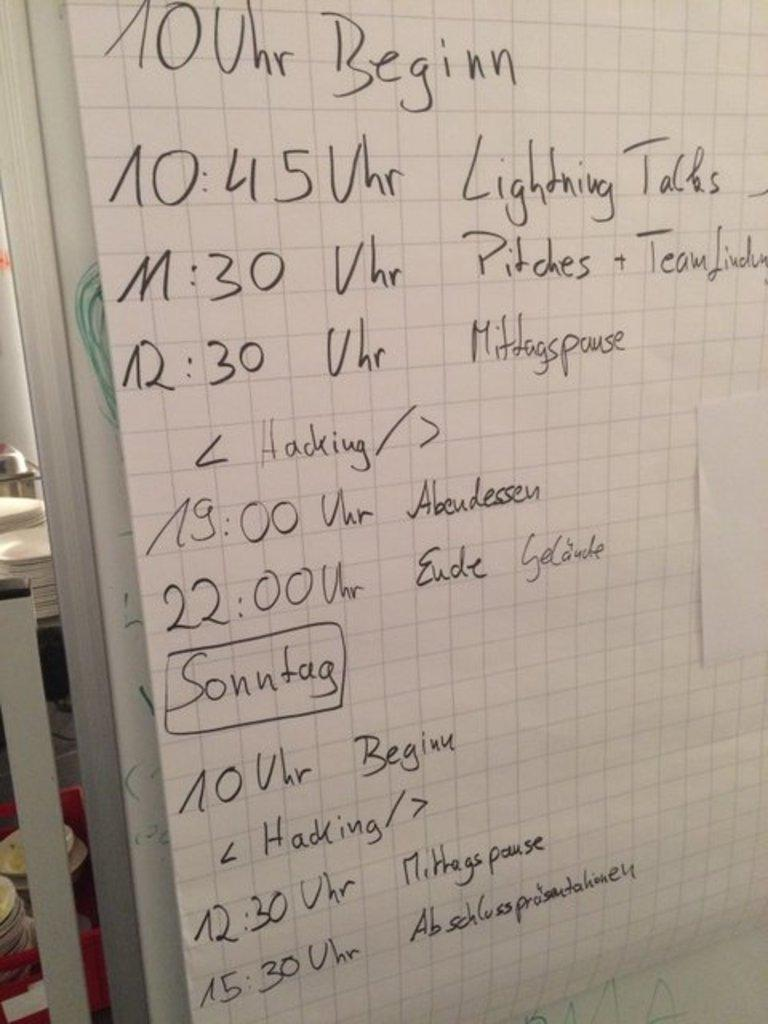<image>
Give a short and clear explanation of the subsequent image. A schedule includes lightening talks listed second at 10:45. 